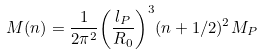Convert formula to latex. <formula><loc_0><loc_0><loc_500><loc_500>M ( n ) = \frac { 1 } { 2 \pi ^ { 2 } } { \left ( \frac { l _ { P } } { R _ { 0 } } \right ) } ^ { 3 } ( n + 1 / 2 ) ^ { 2 } M _ { P }</formula> 